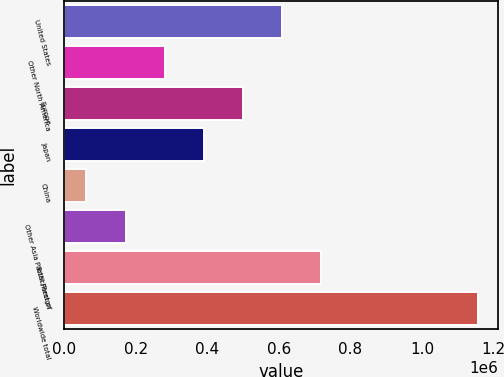<chart> <loc_0><loc_0><loc_500><loc_500><bar_chart><fcel>United States<fcel>Other North America<fcel>Europe<fcel>Japan<fcel>China<fcel>Other Asia Pacific/Rest of<fcel>Total Foreign<fcel>Worldwide total<nl><fcel>609138<fcel>281035<fcel>499771<fcel>390403<fcel>62300<fcel>171668<fcel>718506<fcel>1.15598e+06<nl></chart> 